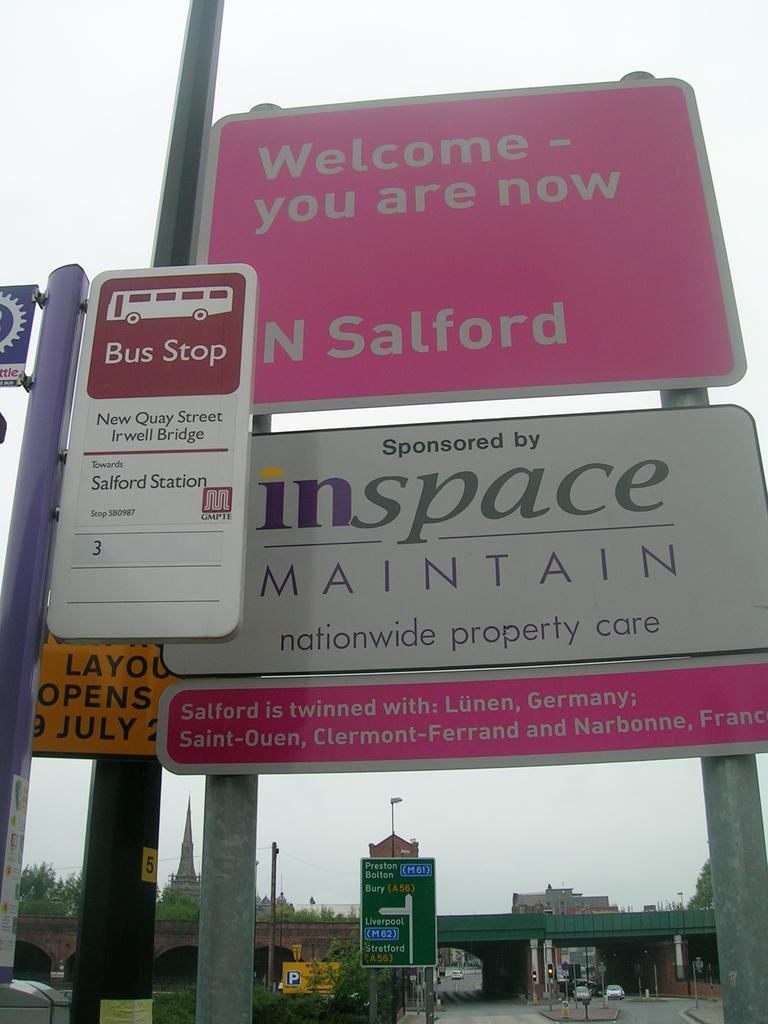With which german town is salford twinned?
Ensure brevity in your answer.  Lunen. 